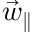Convert formula to latex. <formula><loc_0><loc_0><loc_500><loc_500>\vec { w } _ { \| }</formula> 